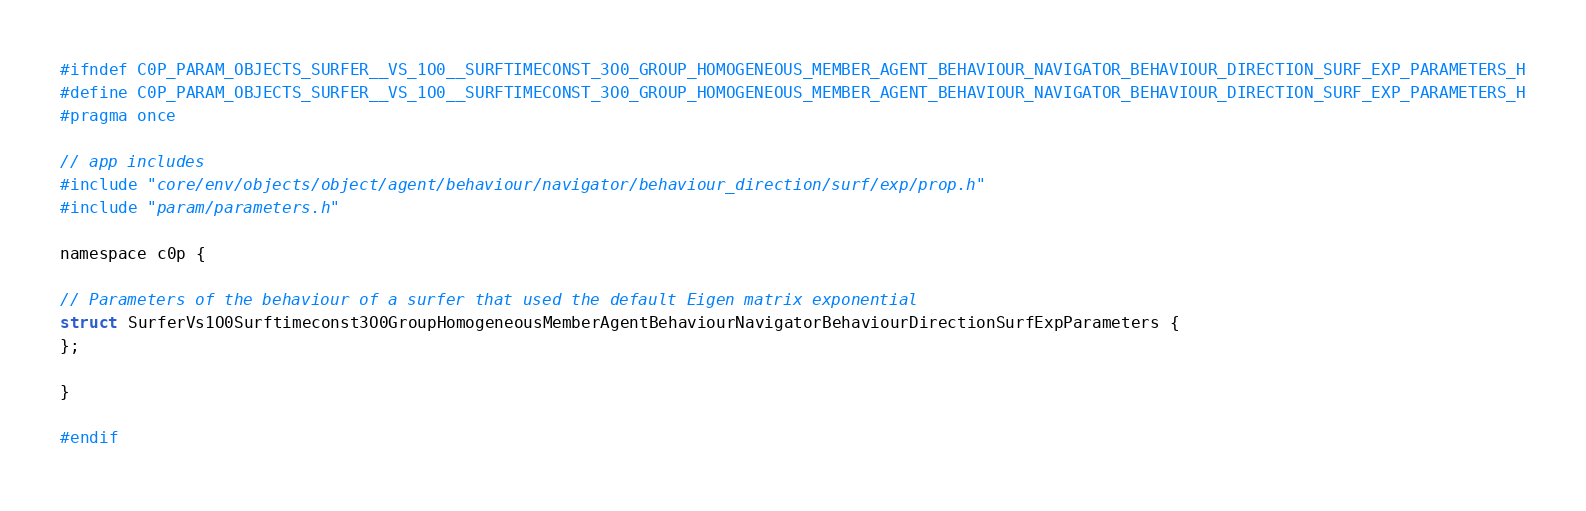Convert code to text. <code><loc_0><loc_0><loc_500><loc_500><_C_>#ifndef C0P_PARAM_OBJECTS_SURFER__VS_1O0__SURFTIMECONST_3O0_GROUP_HOMOGENEOUS_MEMBER_AGENT_BEHAVIOUR_NAVIGATOR_BEHAVIOUR_DIRECTION_SURF_EXP_PARAMETERS_H
#define C0P_PARAM_OBJECTS_SURFER__VS_1O0__SURFTIMECONST_3O0_GROUP_HOMOGENEOUS_MEMBER_AGENT_BEHAVIOUR_NAVIGATOR_BEHAVIOUR_DIRECTION_SURF_EXP_PARAMETERS_H
#pragma once

// app includes
#include "core/env/objects/object/agent/behaviour/navigator/behaviour_direction/surf/exp/prop.h"
#include "param/parameters.h"

namespace c0p {

// Parameters of the behaviour of a surfer that used the default Eigen matrix exponential
struct SurferVs1O0Surftimeconst3O0GroupHomogeneousMemberAgentBehaviourNavigatorBehaviourDirectionSurfExpParameters {
};

}

#endif
</code> 